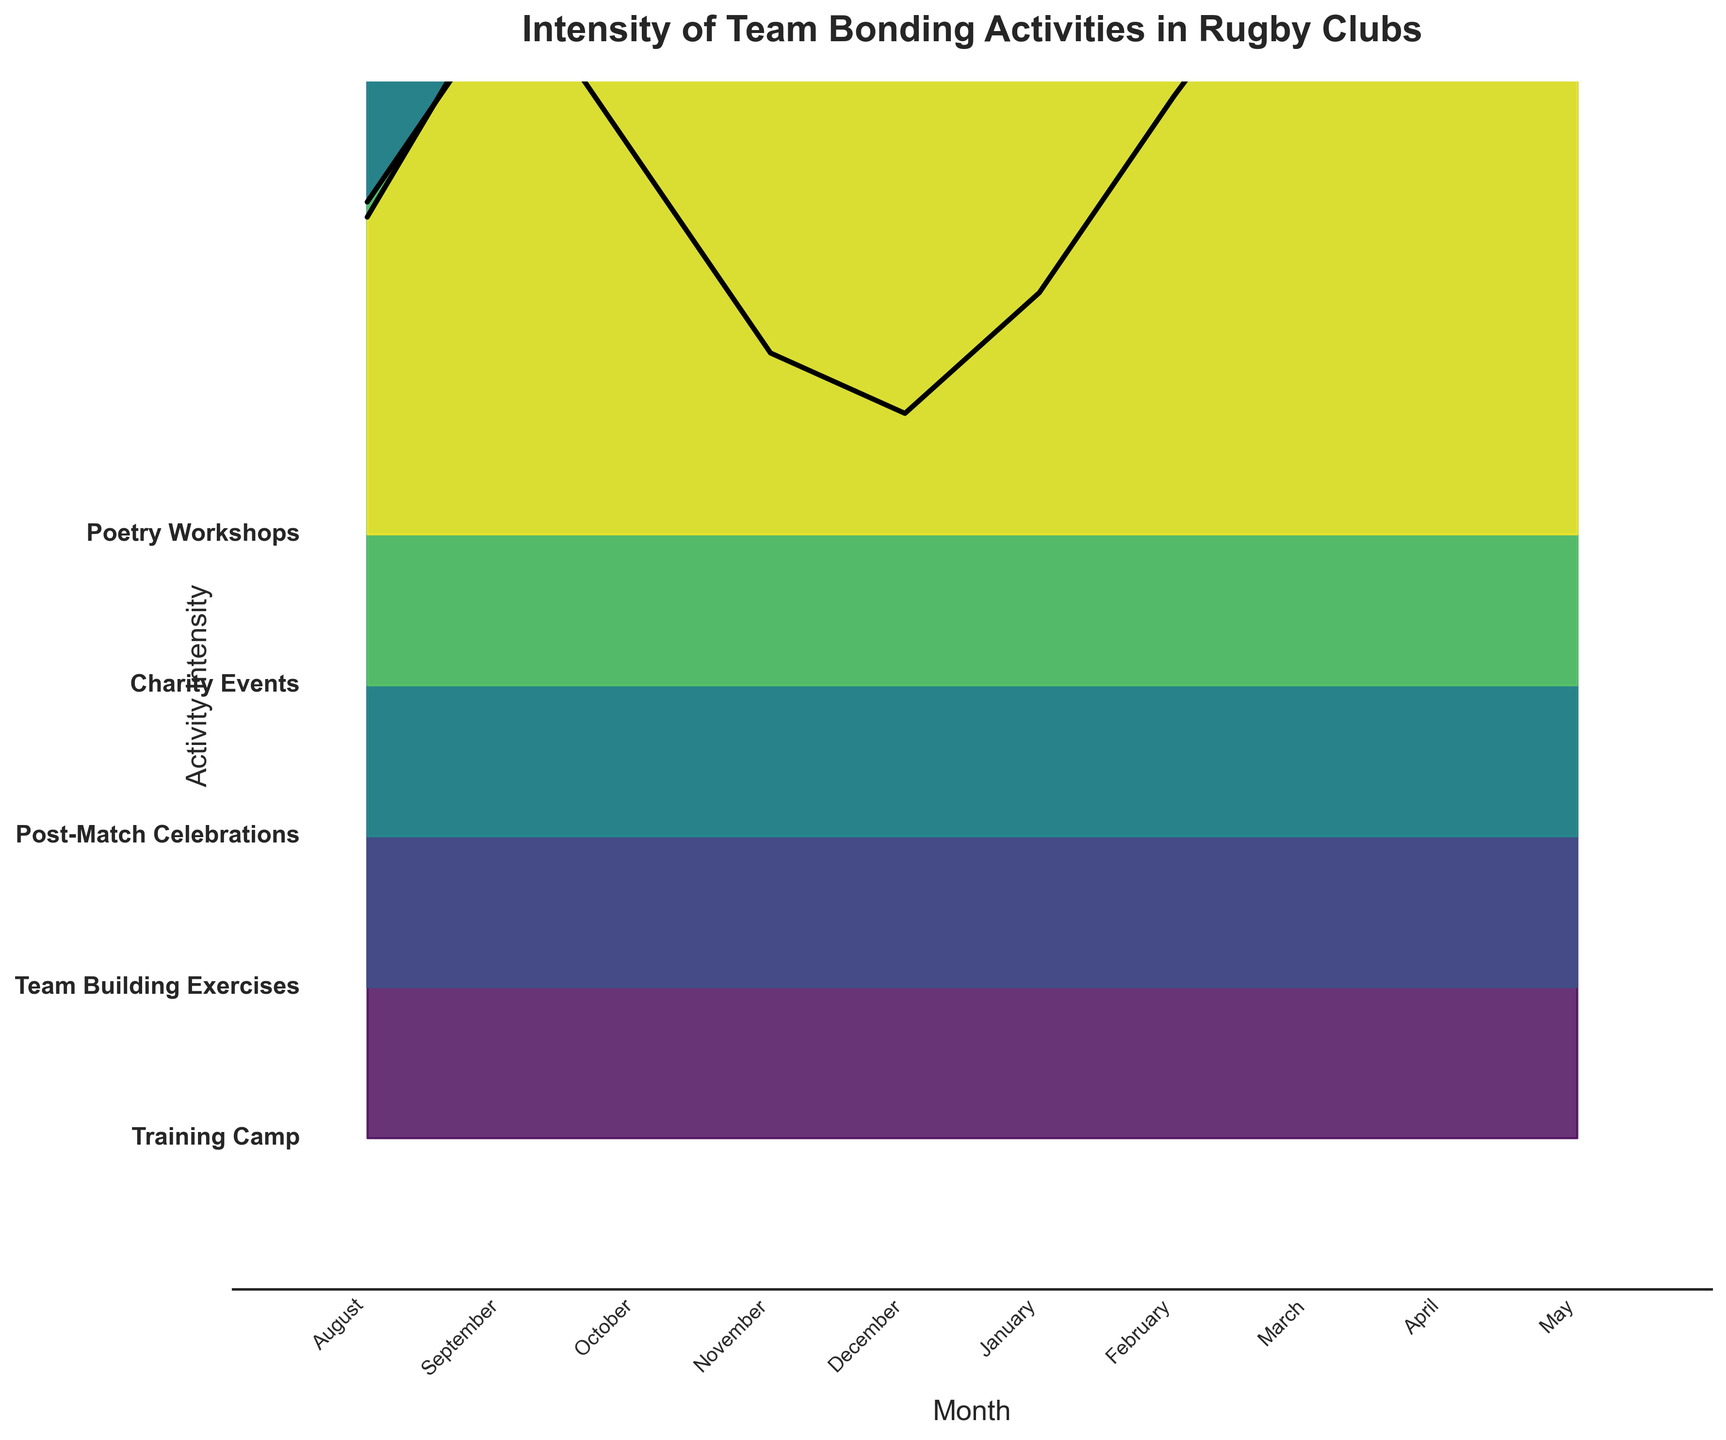What is the title of the figure? The title of the figure is usually located at the top of the chart. In this case, it is prominently shown.
Answer: Intensity of Team Bonding Activities in Rugby Clubs How many months are represented in the figure? The x-axis is labeled with months, and we can count the discrete labels.
Answer: 10 Which month shows the highest intensity for Team Building Exercises? By observing the ridgeline plot for the Team Building Exercises, the highest point on the y-axis can be found in May.
Answer: May What activity has the highest average intensity throughout the season? To find this, one needs to visually estimate the heights of the ridgelines for each activity and find their average. Team Building Exercises have consistently high values.
Answer: Team Building Exercises Which month has the lowest intensity for Poetry Workshops? By looking at the ridgeline for Poetry Workshops, the lowest point on the y-axis can be observed in August.
Answer: August In which month do Charity Events reach their peak intensity? By tracing the ridgeline for Charity Events, the highest point is located in May.
Answer: May Compare the intensity of Post-Match Celebrations in October and March. Which one is higher? By comparing the heights of the ridgelines for Post-Match Celebrations in these two months, March has a higher intensity than October.
Answer: March Across all months, which activity shows the most consistent intensity levels? Consistency can be judged by the flatness of the ridgeline; Team Building Exercises appear very consistent with slight fluctuations.
Answer: Team Building Exercises How does the intensity of Post-Match Celebrations change from November to December? Observing the ridgeline for Post-Match Celebrations, the intensity remains the same from November to December.
Answer: It remains the same What is the most prominent trend for Training Camp intensity from August to May? By examining the changes in the Training Camp ridgeline, a U-shaped trend can be observed, dropping in intensity from August until December and rising again.
Answer: U-shaped 